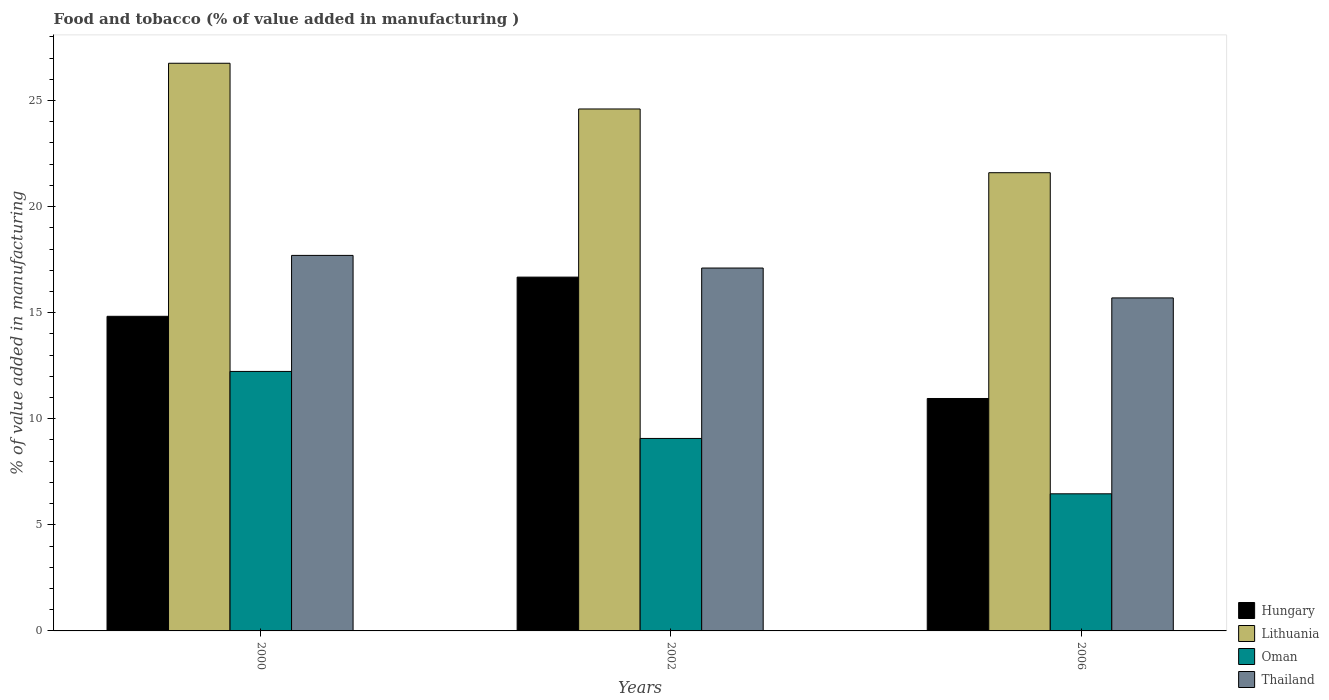How many different coloured bars are there?
Your answer should be compact. 4. How many groups of bars are there?
Offer a very short reply. 3. Are the number of bars per tick equal to the number of legend labels?
Your answer should be compact. Yes. How many bars are there on the 1st tick from the right?
Provide a short and direct response. 4. What is the value added in manufacturing food and tobacco in Thailand in 2000?
Provide a succinct answer. 17.7. Across all years, what is the maximum value added in manufacturing food and tobacco in Thailand?
Your answer should be compact. 17.7. Across all years, what is the minimum value added in manufacturing food and tobacco in Oman?
Your answer should be compact. 6.46. In which year was the value added in manufacturing food and tobacco in Lithuania maximum?
Provide a succinct answer. 2000. In which year was the value added in manufacturing food and tobacco in Lithuania minimum?
Ensure brevity in your answer.  2006. What is the total value added in manufacturing food and tobacco in Lithuania in the graph?
Make the answer very short. 72.95. What is the difference between the value added in manufacturing food and tobacco in Lithuania in 2002 and that in 2006?
Provide a short and direct response. 3. What is the difference between the value added in manufacturing food and tobacco in Oman in 2000 and the value added in manufacturing food and tobacco in Thailand in 2002?
Give a very brief answer. -4.87. What is the average value added in manufacturing food and tobacco in Hungary per year?
Keep it short and to the point. 14.15. In the year 2006, what is the difference between the value added in manufacturing food and tobacco in Thailand and value added in manufacturing food and tobacco in Lithuania?
Give a very brief answer. -5.9. What is the ratio of the value added in manufacturing food and tobacco in Thailand in 2000 to that in 2002?
Ensure brevity in your answer.  1.03. Is the value added in manufacturing food and tobacco in Oman in 2000 less than that in 2002?
Offer a very short reply. No. Is the difference between the value added in manufacturing food and tobacco in Thailand in 2000 and 2006 greater than the difference between the value added in manufacturing food and tobacco in Lithuania in 2000 and 2006?
Give a very brief answer. No. What is the difference between the highest and the second highest value added in manufacturing food and tobacco in Thailand?
Give a very brief answer. 0.6. What is the difference between the highest and the lowest value added in manufacturing food and tobacco in Hungary?
Offer a terse response. 5.72. In how many years, is the value added in manufacturing food and tobacco in Thailand greater than the average value added in manufacturing food and tobacco in Thailand taken over all years?
Give a very brief answer. 2. Is it the case that in every year, the sum of the value added in manufacturing food and tobacco in Hungary and value added in manufacturing food and tobacco in Thailand is greater than the sum of value added in manufacturing food and tobacco in Oman and value added in manufacturing food and tobacco in Lithuania?
Provide a short and direct response. No. What does the 2nd bar from the left in 2006 represents?
Provide a short and direct response. Lithuania. What does the 2nd bar from the right in 2002 represents?
Ensure brevity in your answer.  Oman. How many bars are there?
Make the answer very short. 12. Are all the bars in the graph horizontal?
Provide a succinct answer. No. How many years are there in the graph?
Make the answer very short. 3. Are the values on the major ticks of Y-axis written in scientific E-notation?
Make the answer very short. No. Does the graph contain any zero values?
Your response must be concise. No. Does the graph contain grids?
Your response must be concise. No. Where does the legend appear in the graph?
Your answer should be very brief. Bottom right. How are the legend labels stacked?
Offer a terse response. Vertical. What is the title of the graph?
Provide a succinct answer. Food and tobacco (% of value added in manufacturing ). What is the label or title of the Y-axis?
Your answer should be compact. % of value added in manufacturing. What is the % of value added in manufacturing of Hungary in 2000?
Give a very brief answer. 14.83. What is the % of value added in manufacturing in Lithuania in 2000?
Provide a short and direct response. 26.76. What is the % of value added in manufacturing of Oman in 2000?
Provide a succinct answer. 12.23. What is the % of value added in manufacturing in Thailand in 2000?
Provide a succinct answer. 17.7. What is the % of value added in manufacturing in Hungary in 2002?
Provide a succinct answer. 16.68. What is the % of value added in manufacturing of Lithuania in 2002?
Give a very brief answer. 24.6. What is the % of value added in manufacturing in Oman in 2002?
Give a very brief answer. 9.07. What is the % of value added in manufacturing in Thailand in 2002?
Provide a succinct answer. 17.1. What is the % of value added in manufacturing in Hungary in 2006?
Provide a short and direct response. 10.96. What is the % of value added in manufacturing of Lithuania in 2006?
Offer a very short reply. 21.6. What is the % of value added in manufacturing of Oman in 2006?
Keep it short and to the point. 6.46. What is the % of value added in manufacturing of Thailand in 2006?
Your response must be concise. 15.7. Across all years, what is the maximum % of value added in manufacturing in Hungary?
Offer a very short reply. 16.68. Across all years, what is the maximum % of value added in manufacturing in Lithuania?
Your answer should be compact. 26.76. Across all years, what is the maximum % of value added in manufacturing in Oman?
Offer a terse response. 12.23. Across all years, what is the maximum % of value added in manufacturing in Thailand?
Offer a terse response. 17.7. Across all years, what is the minimum % of value added in manufacturing of Hungary?
Keep it short and to the point. 10.96. Across all years, what is the minimum % of value added in manufacturing in Lithuania?
Your answer should be very brief. 21.6. Across all years, what is the minimum % of value added in manufacturing in Oman?
Your answer should be compact. 6.46. Across all years, what is the minimum % of value added in manufacturing of Thailand?
Provide a succinct answer. 15.7. What is the total % of value added in manufacturing of Hungary in the graph?
Make the answer very short. 42.46. What is the total % of value added in manufacturing in Lithuania in the graph?
Keep it short and to the point. 72.95. What is the total % of value added in manufacturing in Oman in the graph?
Your response must be concise. 27.76. What is the total % of value added in manufacturing in Thailand in the graph?
Your answer should be very brief. 50.5. What is the difference between the % of value added in manufacturing in Hungary in 2000 and that in 2002?
Offer a very short reply. -1.85. What is the difference between the % of value added in manufacturing in Lithuania in 2000 and that in 2002?
Offer a terse response. 2.15. What is the difference between the % of value added in manufacturing of Oman in 2000 and that in 2002?
Provide a short and direct response. 3.16. What is the difference between the % of value added in manufacturing of Thailand in 2000 and that in 2002?
Make the answer very short. 0.6. What is the difference between the % of value added in manufacturing in Hungary in 2000 and that in 2006?
Offer a terse response. 3.87. What is the difference between the % of value added in manufacturing in Lithuania in 2000 and that in 2006?
Offer a terse response. 5.16. What is the difference between the % of value added in manufacturing in Oman in 2000 and that in 2006?
Provide a short and direct response. 5.77. What is the difference between the % of value added in manufacturing of Thailand in 2000 and that in 2006?
Provide a short and direct response. 2. What is the difference between the % of value added in manufacturing in Hungary in 2002 and that in 2006?
Make the answer very short. 5.72. What is the difference between the % of value added in manufacturing in Lithuania in 2002 and that in 2006?
Offer a very short reply. 3. What is the difference between the % of value added in manufacturing in Oman in 2002 and that in 2006?
Your response must be concise. 2.61. What is the difference between the % of value added in manufacturing of Thailand in 2002 and that in 2006?
Make the answer very short. 1.41. What is the difference between the % of value added in manufacturing of Hungary in 2000 and the % of value added in manufacturing of Lithuania in 2002?
Keep it short and to the point. -9.77. What is the difference between the % of value added in manufacturing of Hungary in 2000 and the % of value added in manufacturing of Oman in 2002?
Your response must be concise. 5.76. What is the difference between the % of value added in manufacturing of Hungary in 2000 and the % of value added in manufacturing of Thailand in 2002?
Your response must be concise. -2.27. What is the difference between the % of value added in manufacturing in Lithuania in 2000 and the % of value added in manufacturing in Oman in 2002?
Your answer should be compact. 17.68. What is the difference between the % of value added in manufacturing of Lithuania in 2000 and the % of value added in manufacturing of Thailand in 2002?
Your answer should be very brief. 9.65. What is the difference between the % of value added in manufacturing in Oman in 2000 and the % of value added in manufacturing in Thailand in 2002?
Offer a very short reply. -4.87. What is the difference between the % of value added in manufacturing in Hungary in 2000 and the % of value added in manufacturing in Lithuania in 2006?
Your response must be concise. -6.77. What is the difference between the % of value added in manufacturing of Hungary in 2000 and the % of value added in manufacturing of Oman in 2006?
Ensure brevity in your answer.  8.37. What is the difference between the % of value added in manufacturing of Hungary in 2000 and the % of value added in manufacturing of Thailand in 2006?
Your answer should be compact. -0.87. What is the difference between the % of value added in manufacturing of Lithuania in 2000 and the % of value added in manufacturing of Oman in 2006?
Offer a very short reply. 20.29. What is the difference between the % of value added in manufacturing of Lithuania in 2000 and the % of value added in manufacturing of Thailand in 2006?
Ensure brevity in your answer.  11.06. What is the difference between the % of value added in manufacturing in Oman in 2000 and the % of value added in manufacturing in Thailand in 2006?
Your answer should be compact. -3.47. What is the difference between the % of value added in manufacturing of Hungary in 2002 and the % of value added in manufacturing of Lithuania in 2006?
Make the answer very short. -4.92. What is the difference between the % of value added in manufacturing of Hungary in 2002 and the % of value added in manufacturing of Oman in 2006?
Offer a terse response. 10.21. What is the difference between the % of value added in manufacturing in Hungary in 2002 and the % of value added in manufacturing in Thailand in 2006?
Provide a short and direct response. 0.98. What is the difference between the % of value added in manufacturing of Lithuania in 2002 and the % of value added in manufacturing of Oman in 2006?
Offer a terse response. 18.14. What is the difference between the % of value added in manufacturing of Lithuania in 2002 and the % of value added in manufacturing of Thailand in 2006?
Keep it short and to the point. 8.9. What is the difference between the % of value added in manufacturing in Oman in 2002 and the % of value added in manufacturing in Thailand in 2006?
Give a very brief answer. -6.62. What is the average % of value added in manufacturing of Hungary per year?
Provide a short and direct response. 14.15. What is the average % of value added in manufacturing of Lithuania per year?
Give a very brief answer. 24.32. What is the average % of value added in manufacturing in Oman per year?
Give a very brief answer. 9.25. What is the average % of value added in manufacturing in Thailand per year?
Keep it short and to the point. 16.83. In the year 2000, what is the difference between the % of value added in manufacturing in Hungary and % of value added in manufacturing in Lithuania?
Your response must be concise. -11.93. In the year 2000, what is the difference between the % of value added in manufacturing of Hungary and % of value added in manufacturing of Oman?
Your answer should be very brief. 2.6. In the year 2000, what is the difference between the % of value added in manufacturing in Hungary and % of value added in manufacturing in Thailand?
Give a very brief answer. -2.87. In the year 2000, what is the difference between the % of value added in manufacturing in Lithuania and % of value added in manufacturing in Oman?
Provide a short and direct response. 14.52. In the year 2000, what is the difference between the % of value added in manufacturing in Lithuania and % of value added in manufacturing in Thailand?
Your response must be concise. 9.06. In the year 2000, what is the difference between the % of value added in manufacturing in Oman and % of value added in manufacturing in Thailand?
Offer a very short reply. -5.47. In the year 2002, what is the difference between the % of value added in manufacturing of Hungary and % of value added in manufacturing of Lithuania?
Your answer should be compact. -7.92. In the year 2002, what is the difference between the % of value added in manufacturing in Hungary and % of value added in manufacturing in Oman?
Keep it short and to the point. 7.6. In the year 2002, what is the difference between the % of value added in manufacturing in Hungary and % of value added in manufacturing in Thailand?
Your answer should be compact. -0.43. In the year 2002, what is the difference between the % of value added in manufacturing in Lithuania and % of value added in manufacturing in Oman?
Give a very brief answer. 15.53. In the year 2002, what is the difference between the % of value added in manufacturing in Lithuania and % of value added in manufacturing in Thailand?
Offer a very short reply. 7.5. In the year 2002, what is the difference between the % of value added in manufacturing of Oman and % of value added in manufacturing of Thailand?
Make the answer very short. -8.03. In the year 2006, what is the difference between the % of value added in manufacturing of Hungary and % of value added in manufacturing of Lithuania?
Offer a very short reply. -10.64. In the year 2006, what is the difference between the % of value added in manufacturing in Hungary and % of value added in manufacturing in Oman?
Your answer should be compact. 4.49. In the year 2006, what is the difference between the % of value added in manufacturing of Hungary and % of value added in manufacturing of Thailand?
Offer a terse response. -4.74. In the year 2006, what is the difference between the % of value added in manufacturing of Lithuania and % of value added in manufacturing of Oman?
Your answer should be very brief. 15.13. In the year 2006, what is the difference between the % of value added in manufacturing of Lithuania and % of value added in manufacturing of Thailand?
Your answer should be compact. 5.9. In the year 2006, what is the difference between the % of value added in manufacturing in Oman and % of value added in manufacturing in Thailand?
Your response must be concise. -9.23. What is the ratio of the % of value added in manufacturing in Hungary in 2000 to that in 2002?
Make the answer very short. 0.89. What is the ratio of the % of value added in manufacturing in Lithuania in 2000 to that in 2002?
Ensure brevity in your answer.  1.09. What is the ratio of the % of value added in manufacturing of Oman in 2000 to that in 2002?
Make the answer very short. 1.35. What is the ratio of the % of value added in manufacturing in Thailand in 2000 to that in 2002?
Your answer should be compact. 1.03. What is the ratio of the % of value added in manufacturing of Hungary in 2000 to that in 2006?
Your answer should be very brief. 1.35. What is the ratio of the % of value added in manufacturing of Lithuania in 2000 to that in 2006?
Provide a short and direct response. 1.24. What is the ratio of the % of value added in manufacturing of Oman in 2000 to that in 2006?
Your response must be concise. 1.89. What is the ratio of the % of value added in manufacturing of Thailand in 2000 to that in 2006?
Offer a very short reply. 1.13. What is the ratio of the % of value added in manufacturing of Hungary in 2002 to that in 2006?
Your answer should be compact. 1.52. What is the ratio of the % of value added in manufacturing of Lithuania in 2002 to that in 2006?
Offer a terse response. 1.14. What is the ratio of the % of value added in manufacturing in Oman in 2002 to that in 2006?
Provide a succinct answer. 1.4. What is the ratio of the % of value added in manufacturing in Thailand in 2002 to that in 2006?
Provide a short and direct response. 1.09. What is the difference between the highest and the second highest % of value added in manufacturing in Hungary?
Provide a short and direct response. 1.85. What is the difference between the highest and the second highest % of value added in manufacturing in Lithuania?
Provide a short and direct response. 2.15. What is the difference between the highest and the second highest % of value added in manufacturing in Oman?
Provide a succinct answer. 3.16. What is the difference between the highest and the second highest % of value added in manufacturing of Thailand?
Provide a succinct answer. 0.6. What is the difference between the highest and the lowest % of value added in manufacturing in Hungary?
Provide a succinct answer. 5.72. What is the difference between the highest and the lowest % of value added in manufacturing of Lithuania?
Make the answer very short. 5.16. What is the difference between the highest and the lowest % of value added in manufacturing in Oman?
Provide a short and direct response. 5.77. What is the difference between the highest and the lowest % of value added in manufacturing of Thailand?
Provide a short and direct response. 2. 